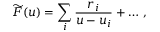<formula> <loc_0><loc_0><loc_500><loc_500>\widetilde { F } ( u ) = \sum _ { i } { \frac { r _ { i } } { u - u _ { i } } } + \dots \, ,</formula> 